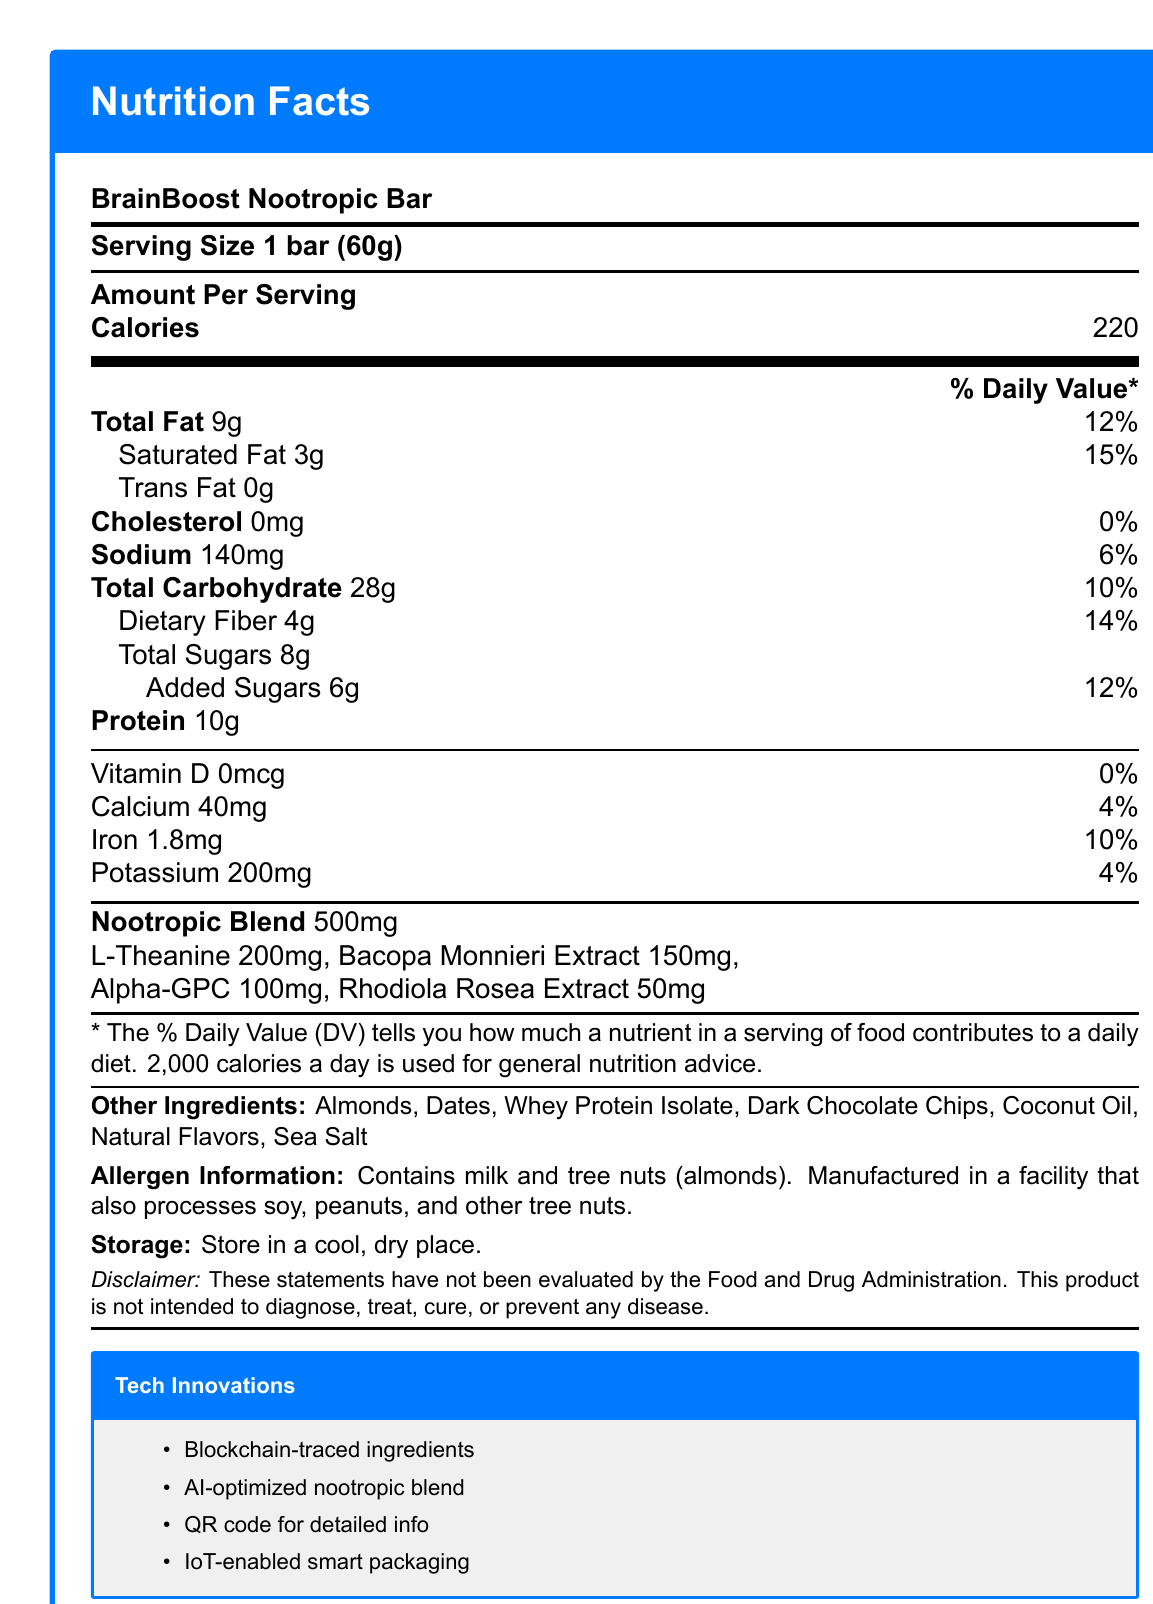what is the serving size? The serving size is mentioned clearly at the top of the Nutrition Facts label as "Serving Size 1 bar (60g)."
Answer: 1 bar (60g) how many calories are in one serving of BrainBoost Nootropic Bar? The label shows that one serving contains 220 calories.
Answer: 220 what is the total carbohydrate content in one bar? The document indicates that the total carbohydrate content is 28g per serving.
Answer: 28g How much protein does one BrainBoost Nootropic Bar contain? The Nutrition Facts label lists protein content as 10g per serving.
Answer: 10g name two ingredients from the nootropic blend The nootropic blend section lists L-Theanine (200mg) and Bacopa Monnieri Extract (150mg) as ingredients.
Answer: L-Theanine, Bacopa Monnieri Extract How much sodium is in one BrainBoost Nootropic Bar? The Nutrition Facts label shows that there is 140mg of sodium in one serving.
Answer: 140mg Does the BrainBoost Nootropic Bar contain any cholesterol? The document states that the cholesterol content is 0mg, which means there is no cholesterol present.
Answer: No which of the following is not listed as an ingredient in the BrainBoost Nootropic Bar? A. Almonds B. Dates C. Peanuts D. Whey Protein Isolate The ingredients listed include Almonds, Dates, Whey Protein Isolate, but not Peanuts.
Answer: C. Peanuts What is the percentage of the daily value for iron in one serving of the BrainBoost Nootropic Bar? A. 4% B. 6% C. 10% D. 15% The label indicates that one serving provides 10% of the daily value for iron.
Answer: C. 10% True/False: The BrainBoost Nootropic Bar is intended to diagnose, treat, cure, or prevent any disease. The disclaimer clearly states that the product is not intended to diagnose, treat, cure, or prevent any disease.
Answer: False Summarize the main idea of this Nutrition Facts label. The document provides a comprehensive overview of the BrainBoost Nootropic Bar, highlighting its nutritional content, cognitive-enhancing ingredients, and various technological innovations designed to enhance product transparency and consumer experience.
Answer: The Nutrition Facts label for the BrainBoost Nootropic Bar provides detailed information on serving size, calories, macronutrients, vitamins, and nootropic ingredients. It also includes allergen information, storage instructions, and tech innovations like blockchain traceability, AI formulation, and smart packaging. what is the exact amount of L-Theanine in the BrainBoost Nootropic Bar? The amount of L-Theanine is specifically listed as 200mg in the nootropic blend section.
Answer: 200mg Where can I find detailed ingredient information and cognitive performance studies related to the BrainBoost Nootropic Bar? The document mentions that scanning the QR code will provide detailed ingredient information and cognitive performance studies.
Answer: By scanning the QR code Are the ingredients in the BrainBoost Nootropic Bar sourced using blockchain technology? The tech innovations section states that ingredients are blockchain-traced for enhanced traceability.
Answer: Yes How many grams of dietary fiber are in the BrainBoost Nootropic Bar? The label indicates that there are 4g of dietary fiber in one serving.
Answer: 4g What is the amount of Vitamin D present in one BrainBoost Nootropic Bar? The document lists the Vitamin D content as 0mcg.
Answer: 0mcg What machine learning algorithms were used to optimize the nootropic blend in the BrainBoost Nootropic Bar? The document simply states that the nootropic blend was optimized using machine learning algorithms but does not specify which algorithms were used.
Answer: Cannot be determined 